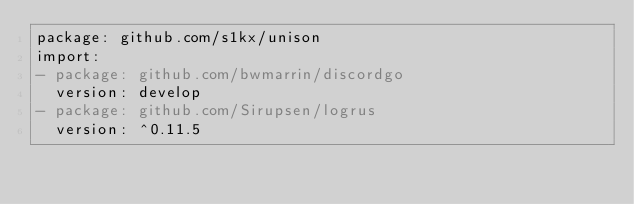Convert code to text. <code><loc_0><loc_0><loc_500><loc_500><_YAML_>package: github.com/s1kx/unison
import:
- package: github.com/bwmarrin/discordgo
  version: develop
- package: github.com/Sirupsen/logrus
  version: ^0.11.5
</code> 